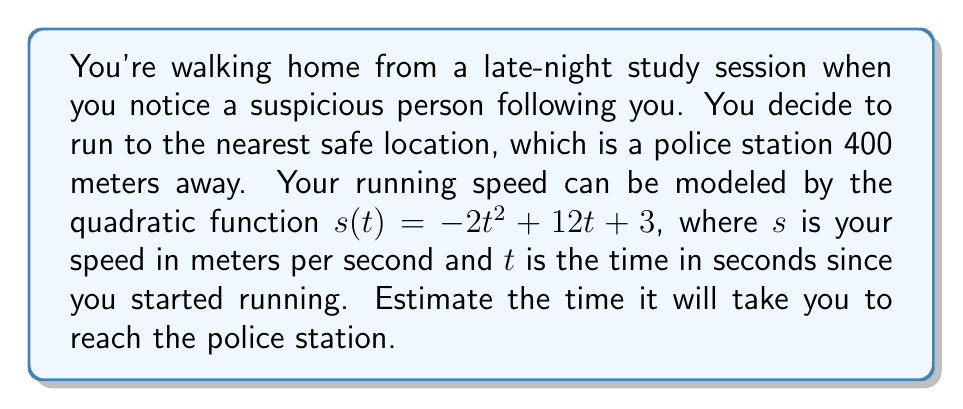Provide a solution to this math problem. To solve this problem, we need to find the total distance traveled and then determine the time it takes to cover that distance. Let's break it down step by step:

1) The distance function $d(t)$ is the integral of the speed function $s(t)$:

   $d(t) = \int s(t) dt = \int (-2t^2 + 12t + 3) dt$

2) Integrating this function:

   $d(t) = -\frac{2}{3}t^3 + 6t^2 + 3t + C$

3) We know that at $t=0$, $d(0)=0$, so $C=0$. Therefore:

   $d(t) = -\frac{2}{3}t^3 + 6t^2 + 3t$

4) We need to find $t$ when $d(t) = 400$:

   $400 = -\frac{2}{3}t^3 + 6t^2 + 3t$

5) This cubic equation is difficult to solve analytically. We can use numerical methods or graphing to estimate the solution.

6) Using a graphing calculator or computer software, we can find that this equation is satisfied when $t \approx 10.7$ seconds.

Therefore, it will take approximately 10.7 seconds to reach the police station.
Answer: Approximately 10.7 seconds 